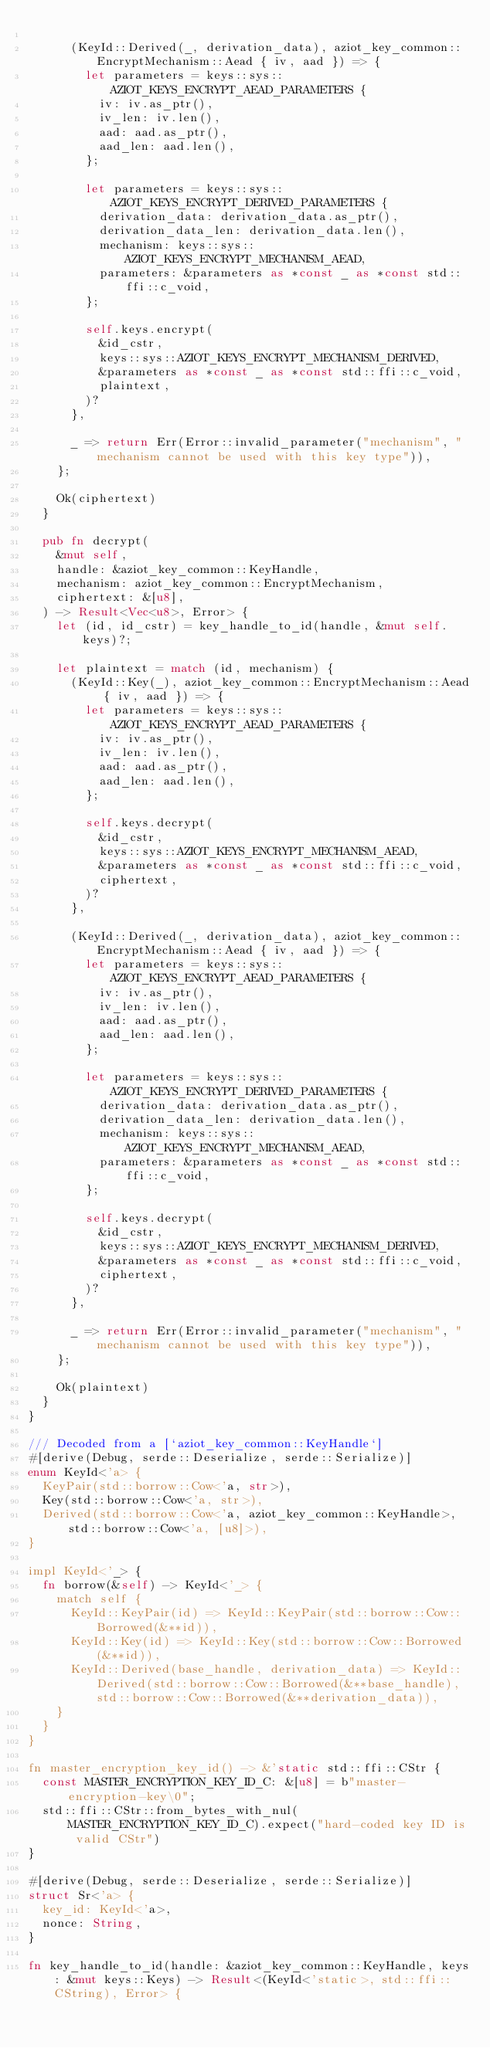<code> <loc_0><loc_0><loc_500><loc_500><_Rust_>
			(KeyId::Derived(_, derivation_data), aziot_key_common::EncryptMechanism::Aead { iv, aad }) => {
				let parameters = keys::sys::AZIOT_KEYS_ENCRYPT_AEAD_PARAMETERS {
					iv: iv.as_ptr(),
					iv_len: iv.len(),
					aad: aad.as_ptr(),
					aad_len: aad.len(),
				};

				let parameters = keys::sys::AZIOT_KEYS_ENCRYPT_DERIVED_PARAMETERS {
					derivation_data: derivation_data.as_ptr(),
					derivation_data_len: derivation_data.len(),
					mechanism: keys::sys::AZIOT_KEYS_ENCRYPT_MECHANISM_AEAD,
					parameters: &parameters as *const _ as *const std::ffi::c_void,
				};

				self.keys.encrypt(
					&id_cstr,
					keys::sys::AZIOT_KEYS_ENCRYPT_MECHANISM_DERIVED,
					&parameters as *const _ as *const std::ffi::c_void,
					plaintext,
				)?
			},

			_ => return Err(Error::invalid_parameter("mechanism", "mechanism cannot be used with this key type")),
		};

		Ok(ciphertext)
	}

	pub fn decrypt(
		&mut self,
		handle: &aziot_key_common::KeyHandle,
		mechanism: aziot_key_common::EncryptMechanism,
		ciphertext: &[u8],
	) -> Result<Vec<u8>, Error> {
		let (id, id_cstr) = key_handle_to_id(handle, &mut self.keys)?;

		let plaintext = match (id, mechanism) {
			(KeyId::Key(_), aziot_key_common::EncryptMechanism::Aead { iv, aad }) => {
				let parameters = keys::sys::AZIOT_KEYS_ENCRYPT_AEAD_PARAMETERS {
					iv: iv.as_ptr(),
					iv_len: iv.len(),
					aad: aad.as_ptr(),
					aad_len: aad.len(),
				};

				self.keys.decrypt(
					&id_cstr,
					keys::sys::AZIOT_KEYS_ENCRYPT_MECHANISM_AEAD,
					&parameters as *const _ as *const std::ffi::c_void,
					ciphertext,
				)?
			},

			(KeyId::Derived(_, derivation_data), aziot_key_common::EncryptMechanism::Aead { iv, aad }) => {
				let parameters = keys::sys::AZIOT_KEYS_ENCRYPT_AEAD_PARAMETERS {
					iv: iv.as_ptr(),
					iv_len: iv.len(),
					aad: aad.as_ptr(),
					aad_len: aad.len(),
				};

				let parameters = keys::sys::AZIOT_KEYS_ENCRYPT_DERIVED_PARAMETERS {
					derivation_data: derivation_data.as_ptr(),
					derivation_data_len: derivation_data.len(),
					mechanism: keys::sys::AZIOT_KEYS_ENCRYPT_MECHANISM_AEAD,
					parameters: &parameters as *const _ as *const std::ffi::c_void,
				};

				self.keys.decrypt(
					&id_cstr,
					keys::sys::AZIOT_KEYS_ENCRYPT_MECHANISM_DERIVED,
					&parameters as *const _ as *const std::ffi::c_void,
					ciphertext,
				)?
			},

			_ => return Err(Error::invalid_parameter("mechanism", "mechanism cannot be used with this key type")),
		};

		Ok(plaintext)
	}
}

/// Decoded from a [`aziot_key_common::KeyHandle`]
#[derive(Debug, serde::Deserialize, serde::Serialize)]
enum KeyId<'a> {
	KeyPair(std::borrow::Cow<'a, str>),
	Key(std::borrow::Cow<'a, str>),
	Derived(std::borrow::Cow<'a, aziot_key_common::KeyHandle>, std::borrow::Cow<'a, [u8]>),
}

impl KeyId<'_> {
	fn borrow(&self) -> KeyId<'_> {
		match self {
			KeyId::KeyPair(id) => KeyId::KeyPair(std::borrow::Cow::Borrowed(&**id)),
			KeyId::Key(id) => KeyId::Key(std::borrow::Cow::Borrowed(&**id)),
			KeyId::Derived(base_handle, derivation_data) => KeyId::Derived(std::borrow::Cow::Borrowed(&**base_handle), std::borrow::Cow::Borrowed(&**derivation_data)),
		}
	}
}

fn master_encryption_key_id() -> &'static std::ffi::CStr {
	const MASTER_ENCRYPTION_KEY_ID_C: &[u8] = b"master-encryption-key\0";
	std::ffi::CStr::from_bytes_with_nul(MASTER_ENCRYPTION_KEY_ID_C).expect("hard-coded key ID is valid CStr")
}

#[derive(Debug, serde::Deserialize, serde::Serialize)]
struct Sr<'a> {
	key_id: KeyId<'a>,
	nonce: String,
}

fn key_handle_to_id(handle: &aziot_key_common::KeyHandle, keys: &mut keys::Keys) -> Result<(KeyId<'static>, std::ffi::CString), Error> {</code> 